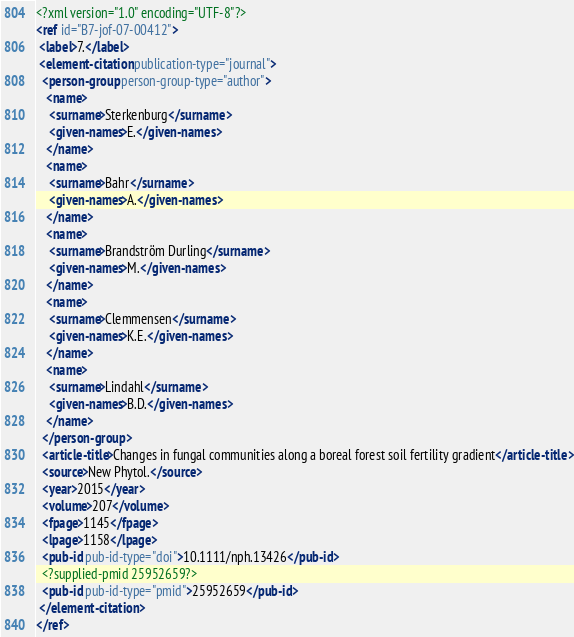<code> <loc_0><loc_0><loc_500><loc_500><_XML_><?xml version="1.0" encoding="UTF-8"?>
<ref id="B7-jof-07-00412">
 <label>7.</label>
 <element-citation publication-type="journal">
  <person-group person-group-type="author">
   <name>
    <surname>Sterkenburg</surname>
    <given-names>E.</given-names>
   </name>
   <name>
    <surname>Bahr</surname>
    <given-names>A.</given-names>
   </name>
   <name>
    <surname>Brandström Durling</surname>
    <given-names>M.</given-names>
   </name>
   <name>
    <surname>Clemmensen</surname>
    <given-names>K.E.</given-names>
   </name>
   <name>
    <surname>Lindahl</surname>
    <given-names>B.D.</given-names>
   </name>
  </person-group>
  <article-title>Changes in fungal communities along a boreal forest soil fertility gradient</article-title>
  <source>New Phytol.</source>
  <year>2015</year>
  <volume>207</volume>
  <fpage>1145</fpage>
  <lpage>1158</lpage>
  <pub-id pub-id-type="doi">10.1111/nph.13426</pub-id>
  <?supplied-pmid 25952659?>
  <pub-id pub-id-type="pmid">25952659</pub-id>
 </element-citation>
</ref>
</code> 